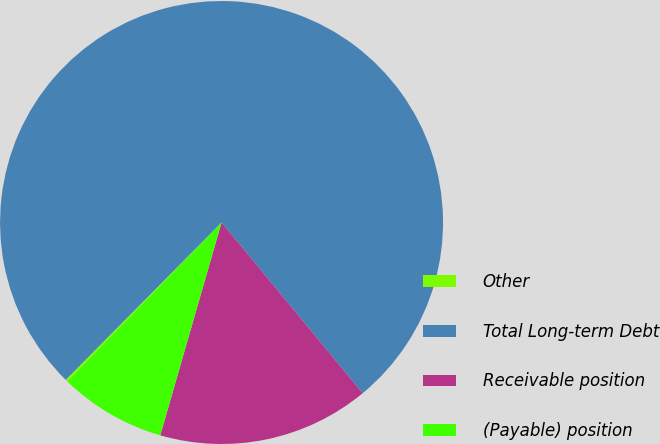Convert chart. <chart><loc_0><loc_0><loc_500><loc_500><pie_chart><fcel>Other<fcel>Total Long-term Debt<fcel>Receivable position<fcel>(Payable) position<nl><fcel>0.16%<fcel>76.59%<fcel>15.45%<fcel>7.8%<nl></chart> 